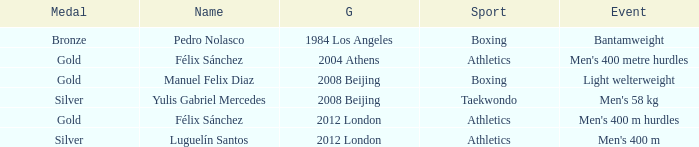Which Games had a Name of manuel felix diaz? 2008 Beijing. 